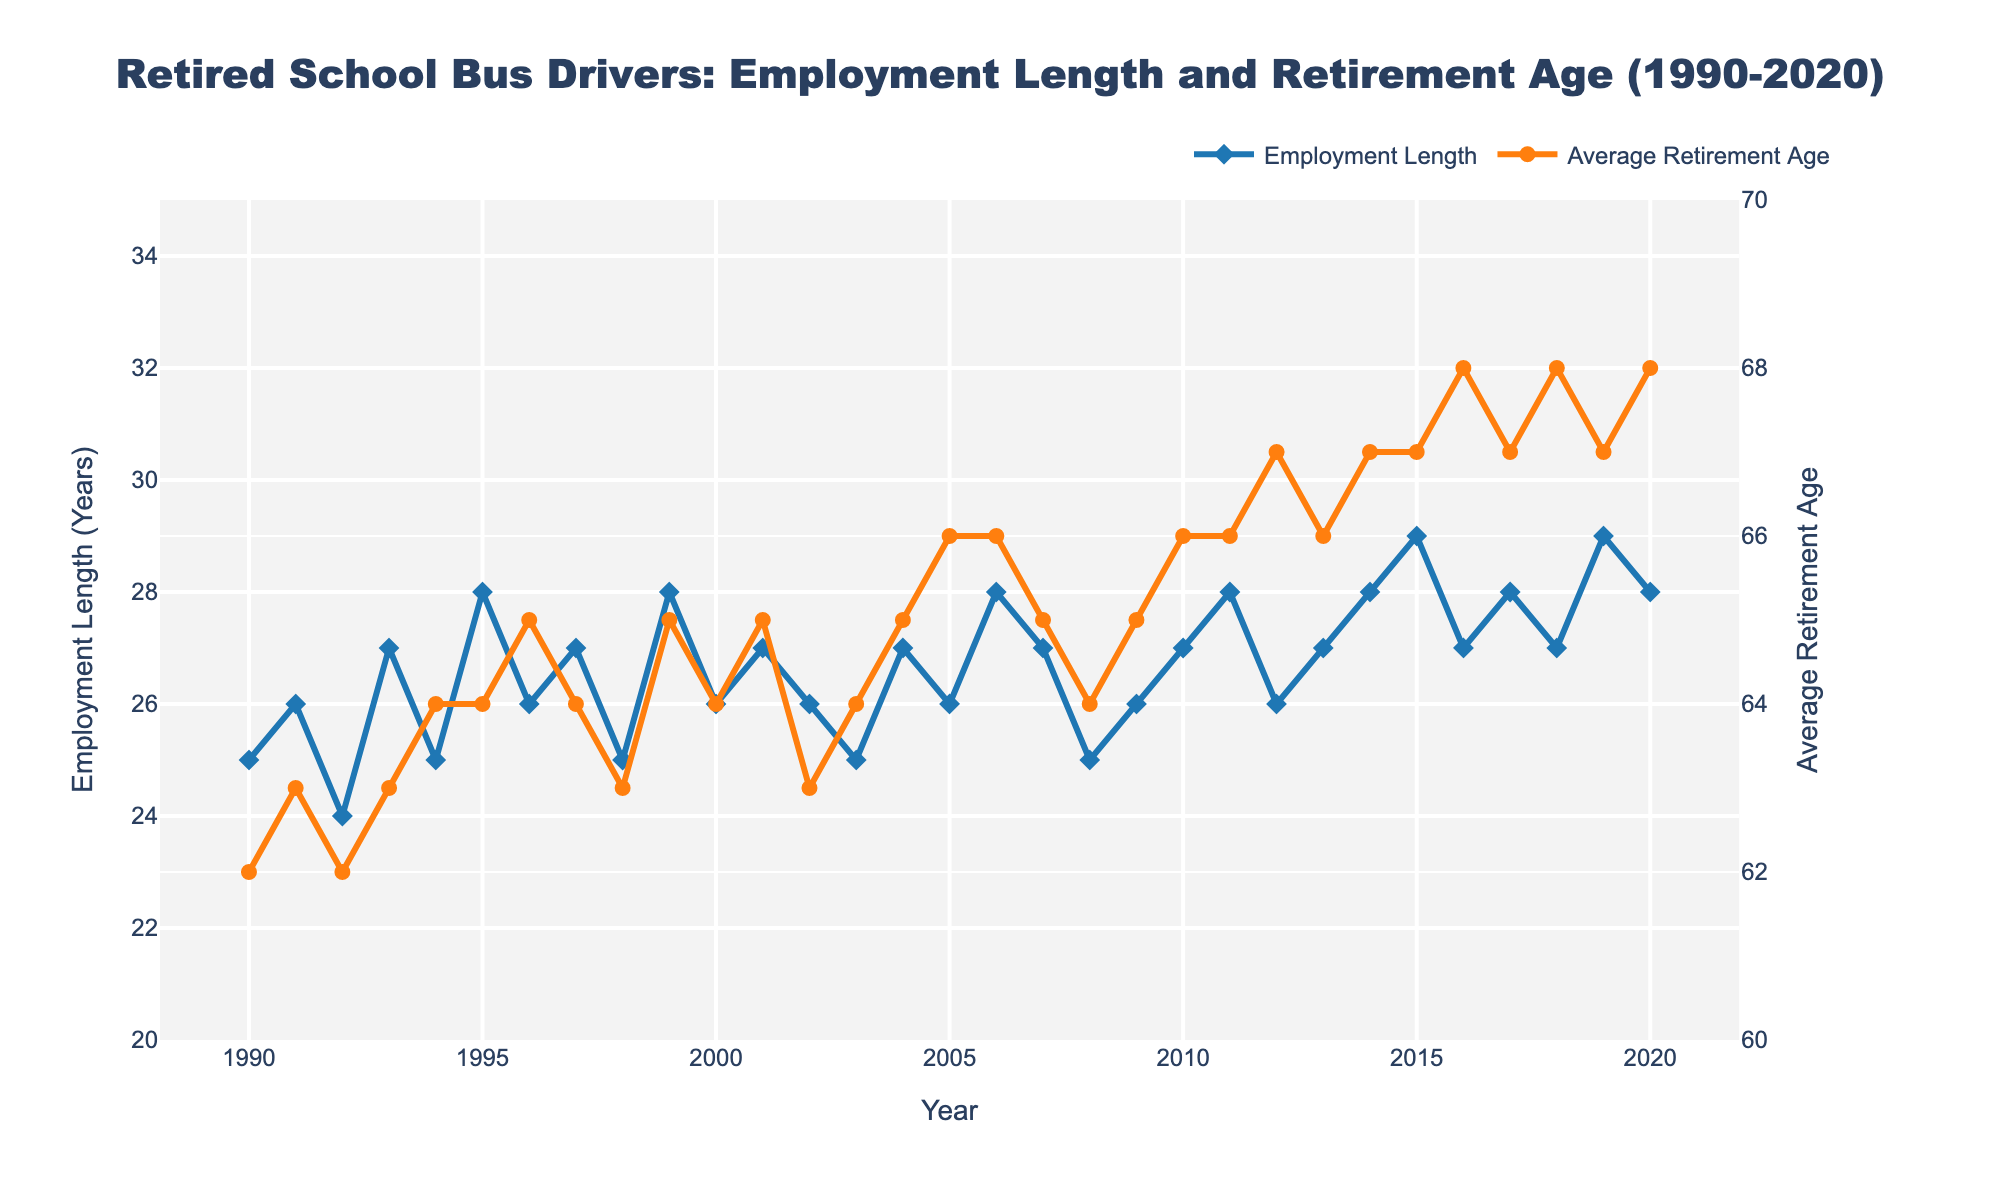What's the title of the figure? The title is located at the top of the figure. It reads: "Retired School Bus Drivers: Employment Length and Retirement Age (1990-2020)"
Answer: Retired School Bus Drivers: Employment Length and Retirement Age (1990-2020) What does the line color represent for employment length data points? The employment length data points are represented by a blue line. Observing the plot, the blue line corresponds to the employment length.
Answer: Blue How many years are covered in the plot? The x-axis represents the years, ranging from 1990 to 2020. The difference between the first and last year plus one gives the total years covered. So, (2020 - 1990 + 1) = 31.
Answer: 31 What was the average employment length in 1995? To determine this, look for the employment length data point marker on the 1995 vertical line. The value is 28 years.
Answer: 28 years What is the trend in average retirement age from 1990 to 2020? Observing the line representing average retirement age, the trend is upward. It starts at 62 in 1990 and rises to 68 by 2020.
Answer: Upward Which year had the highest average retirement age, and what was that age? Look for the peak point on the average retirement age line (orange). The highest point is in 2016, with a value of 68.
Answer: 2016, 68 How does the employment length in 2020 compare to that in 1990? Check the employment length markers for both years. In 1990, it's 25 years, and in 2020, it's 28 years. Thus, employment length increased by 3 years.
Answer: Increased by 3 years In which years did the average retirement age reach 67? By locating the points at which the average retirement age line reaches 67, it is found in the years 2012, 2014, 2015, 2017, and 2019.
Answer: 2012, 2014, 2015, 2017, 2019 What is the difference in employment length from 2005 to 2006? Check the employment length values for 2005 and 2006. In 2005, it is 26 years; in 2006, it is 28 years. Therefore, the difference is 28 - 26 = 2 years.
Answer: 2 years What was the effect on retirement age from 2009 to 2010? Observe the average retirement age markers for 2009 and 2010. In 2009, it's 65; in 2010, it increases to 66. Hence, the retirement age increased by 1 year.
Answer: Increased by 1 year 